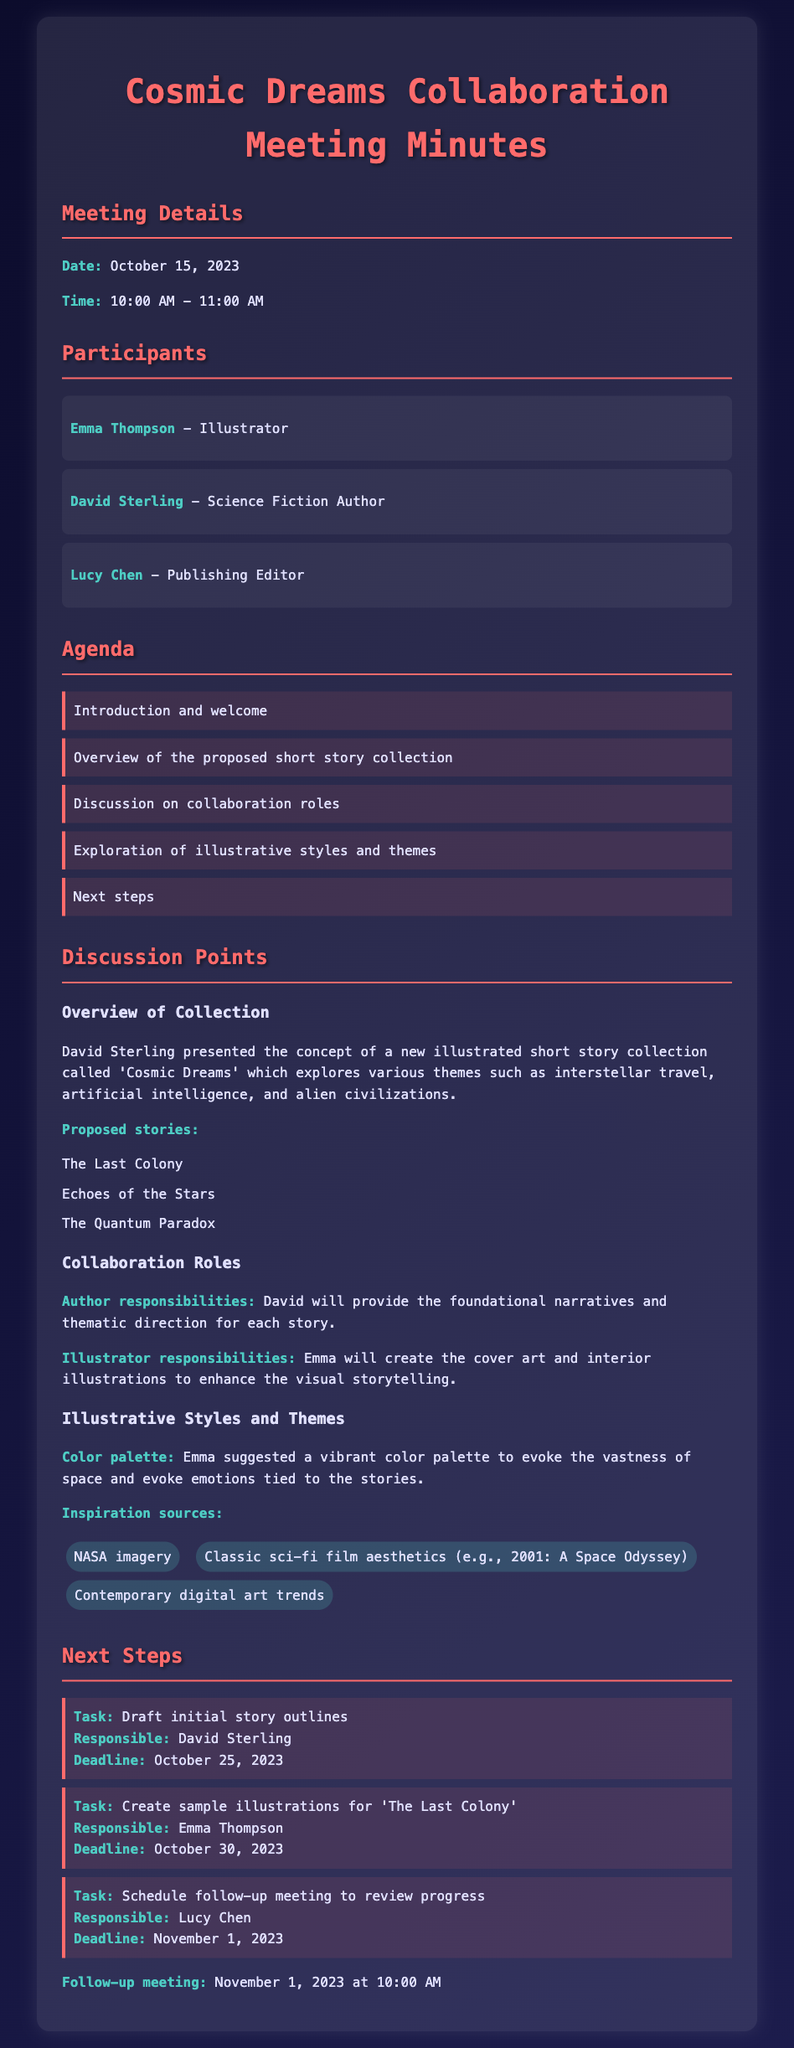What is the date of the meeting? The date of the meeting is mentioned in the Meeting Details section.
Answer: October 15, 2023 Who is responsible for creating the cover art? The responsibilities of each participant are outlined in the document.
Answer: Emma Thompson What is the title of the short story collection? The title is specified in the Overview of Collection section.
Answer: Cosmic Dreams What is the deadline for the initial story outlines? The deadline for this task is found in the Next Steps section.
Answer: October 25, 2023 Which story is mentioned as requiring sample illustrations? The document lists stories for which illustrations are to be created.
Answer: The Last Colony What color palette did Emma suggest? This information is highlighted in the Illustrative Styles and Themes section.
Answer: Vibrant color palette What type of meeting is this document? This document details a specific type of formal gathering.
Answer: Meeting minutes Who will schedule the follow-up meeting? The individual responsible for this task is listed in the Next Steps section.
Answer: Lucy Chen What is the time for the follow-up meeting? The follow-up meeting details are provided at the end of the document.
Answer: 10:00 AM 